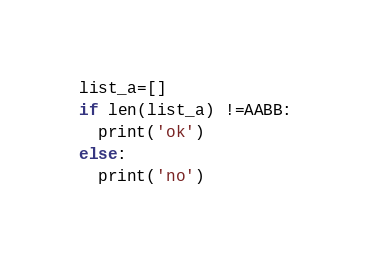Convert code to text. <code><loc_0><loc_0><loc_500><loc_500><_Python_>list_a=[]
if len(list_a) !=AABB:
  print('ok')
else:
  print('no')</code> 